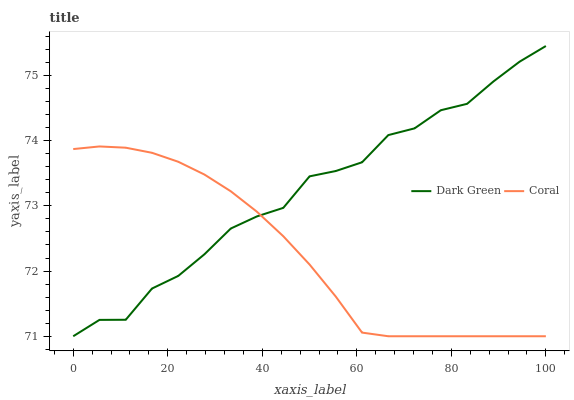Does Coral have the minimum area under the curve?
Answer yes or no. Yes. Does Dark Green have the maximum area under the curve?
Answer yes or no. Yes. Does Dark Green have the minimum area under the curve?
Answer yes or no. No. Is Coral the smoothest?
Answer yes or no. Yes. Is Dark Green the roughest?
Answer yes or no. Yes. Is Dark Green the smoothest?
Answer yes or no. No. Does Coral have the lowest value?
Answer yes or no. Yes. Does Dark Green have the highest value?
Answer yes or no. Yes. Does Coral intersect Dark Green?
Answer yes or no. Yes. Is Coral less than Dark Green?
Answer yes or no. No. Is Coral greater than Dark Green?
Answer yes or no. No. 